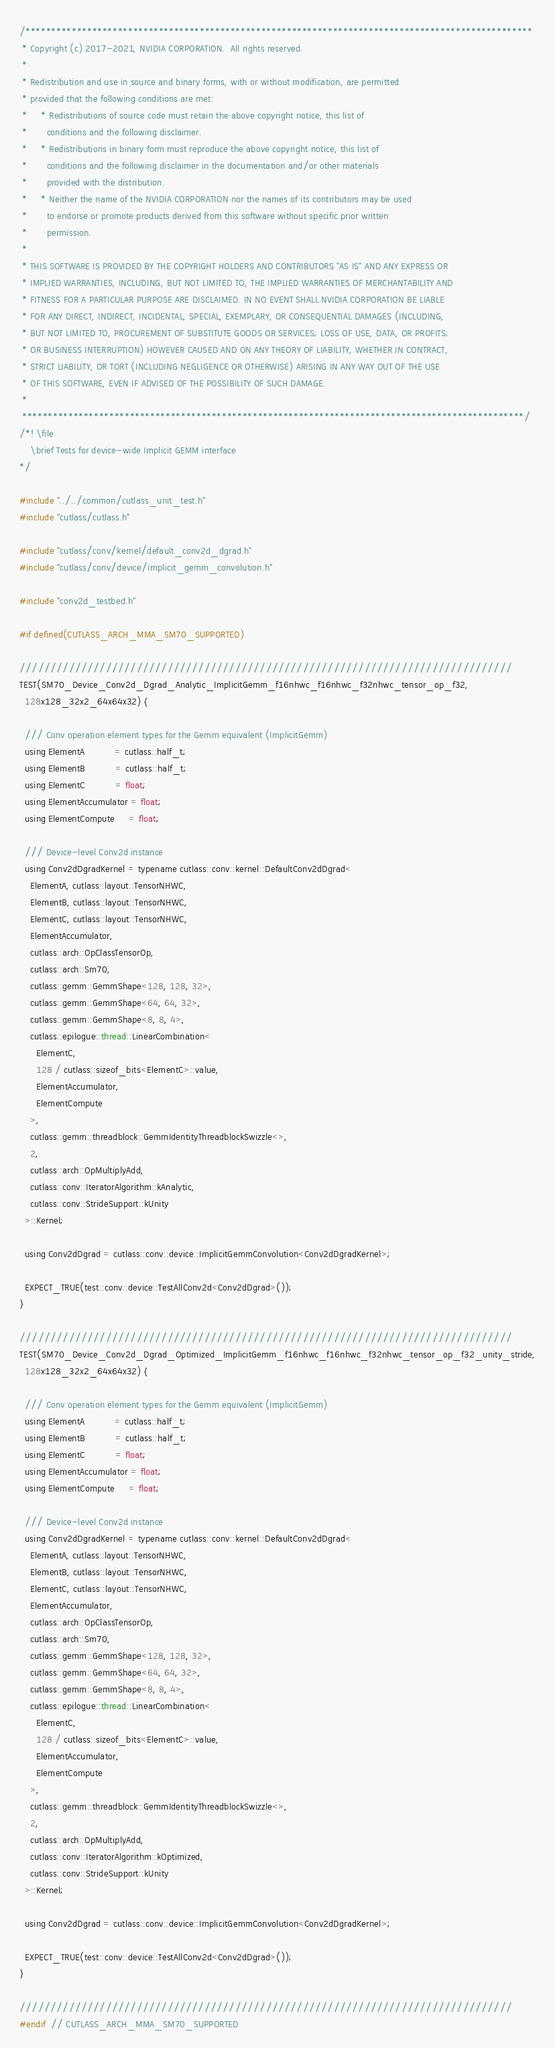Convert code to text. <code><loc_0><loc_0><loc_500><loc_500><_Cuda_>/***************************************************************************************************
 * Copyright (c) 2017-2021, NVIDIA CORPORATION.  All rights reserved.
 *
 * Redistribution and use in source and binary forms, with or without modification, are permitted
 * provided that the following conditions are met:
 *     * Redistributions of source code must retain the above copyright notice, this list of
 *       conditions and the following disclaimer.
 *     * Redistributions in binary form must reproduce the above copyright notice, this list of
 *       conditions and the following disclaimer in the documentation and/or other materials
 *       provided with the distribution.
 *     * Neither the name of the NVIDIA CORPORATION nor the names of its contributors may be used
 *       to endorse or promote products derived from this software without specific prior written
 *       permission.
 *
 * THIS SOFTWARE IS PROVIDED BY THE COPYRIGHT HOLDERS AND CONTRIBUTORS "AS IS" AND ANY EXPRESS OR
 * IMPLIED WARRANTIES, INCLUDING, BUT NOT LIMITED TO, THE IMPLIED WARRANTIES OF MERCHANTABILITY AND
 * FITNESS FOR A PARTICULAR PURPOSE ARE DISCLAIMED. IN NO EVENT SHALL NVIDIA CORPORATION BE LIABLE
 * FOR ANY DIRECT, INDIRECT, INCIDENTAL, SPECIAL, EXEMPLARY, OR CONSEQUENTIAL DAMAGES (INCLUDING,
 * BUT NOT LIMITED TO, PROCUREMENT OF SUBSTITUTE GOODS OR SERVICES; LOSS OF USE, DATA, OR PROFITS;
 * OR BUSINESS INTERRUPTION) HOWEVER CAUSED AND ON ANY THEORY OF LIABILITY, WHETHER IN CONTRACT,
 * STRICT LIABILITY, OR TORT (INCLUDING NEGLIGENCE OR OTHERWISE) ARISING IN ANY WAY OUT OF THE USE
 * OF THIS SOFTWARE, EVEN IF ADVISED OF THE POSSIBILITY OF SUCH DAMAGE.
 *
 **************************************************************************************************/
/*! \file
    \brief Tests for device-wide Implicit GEMM interface
*/

#include "../../common/cutlass_unit_test.h"
#include "cutlass/cutlass.h"

#include "cutlass/conv/kernel/default_conv2d_dgrad.h"
#include "cutlass/conv/device/implicit_gemm_convolution.h"

#include "conv2d_testbed.h"

#if defined(CUTLASS_ARCH_MMA_SM70_SUPPORTED)

////////////////////////////////////////////////////////////////////////////////
TEST(SM70_Device_Conv2d_Dgrad_Analytic_ImplicitGemm_f16nhwc_f16nhwc_f32nhwc_tensor_op_f32,
  128x128_32x2_64x64x32) {

  /// Conv operation element types for the Gemm equivalent (ImplicitGemm)
  using ElementA           = cutlass::half_t;
  using ElementB           = cutlass::half_t;
  using ElementC           = float;
  using ElementAccumulator = float;
  using ElementCompute     = float;

  /// Device-level Conv2d instance
  using Conv2dDgradKernel = typename cutlass::conv::kernel::DefaultConv2dDgrad<
    ElementA, cutlass::layout::TensorNHWC,
    ElementB, cutlass::layout::TensorNHWC,
    ElementC, cutlass::layout::TensorNHWC,
    ElementAccumulator,
    cutlass::arch::OpClassTensorOp,
    cutlass::arch::Sm70,
    cutlass::gemm::GemmShape<128, 128, 32>,
    cutlass::gemm::GemmShape<64, 64, 32>,
    cutlass::gemm::GemmShape<8, 8, 4>,
    cutlass::epilogue::thread::LinearCombination<
      ElementC,
      128 / cutlass::sizeof_bits<ElementC>::value,
      ElementAccumulator,
      ElementCompute
    >,
    cutlass::gemm::threadblock::GemmIdentityThreadblockSwizzle<>,
    2,
    cutlass::arch::OpMultiplyAdd,
    cutlass::conv::IteratorAlgorithm::kAnalytic,
    cutlass::conv::StrideSupport::kUnity
  >::Kernel;

  using Conv2dDgrad = cutlass::conv::device::ImplicitGemmConvolution<Conv2dDgradKernel>;

  EXPECT_TRUE(test::conv::device::TestAllConv2d<Conv2dDgrad>());
}

////////////////////////////////////////////////////////////////////////////////
TEST(SM70_Device_Conv2d_Dgrad_Optimized_ImplicitGemm_f16nhwc_f16nhwc_f32nhwc_tensor_op_f32_unity_stride,
  128x128_32x2_64x64x32) {

  /// Conv operation element types for the Gemm equivalent (ImplicitGemm)
  using ElementA           = cutlass::half_t;
  using ElementB           = cutlass::half_t;
  using ElementC           = float;
  using ElementAccumulator = float;
  using ElementCompute     = float;

  /// Device-level Conv2d instance
  using Conv2dDgradKernel = typename cutlass::conv::kernel::DefaultConv2dDgrad<
    ElementA, cutlass::layout::TensorNHWC,
    ElementB, cutlass::layout::TensorNHWC,
    ElementC, cutlass::layout::TensorNHWC,
    ElementAccumulator,
    cutlass::arch::OpClassTensorOp,
    cutlass::arch::Sm70,
    cutlass::gemm::GemmShape<128, 128, 32>,
    cutlass::gemm::GemmShape<64, 64, 32>,
    cutlass::gemm::GemmShape<8, 8, 4>,
    cutlass::epilogue::thread::LinearCombination<
      ElementC,
      128 / cutlass::sizeof_bits<ElementC>::value,
      ElementAccumulator,
      ElementCompute
    >,
    cutlass::gemm::threadblock::GemmIdentityThreadblockSwizzle<>,
    2,
    cutlass::arch::OpMultiplyAdd,
    cutlass::conv::IteratorAlgorithm::kOptimized,
    cutlass::conv::StrideSupport::kUnity
  >::Kernel;

  using Conv2dDgrad = cutlass::conv::device::ImplicitGemmConvolution<Conv2dDgradKernel>;

  EXPECT_TRUE(test::conv::device::TestAllConv2d<Conv2dDgrad>());
}

////////////////////////////////////////////////////////////////////////////////
#endif  // CUTLASS_ARCH_MMA_SM70_SUPPORTED
</code> 